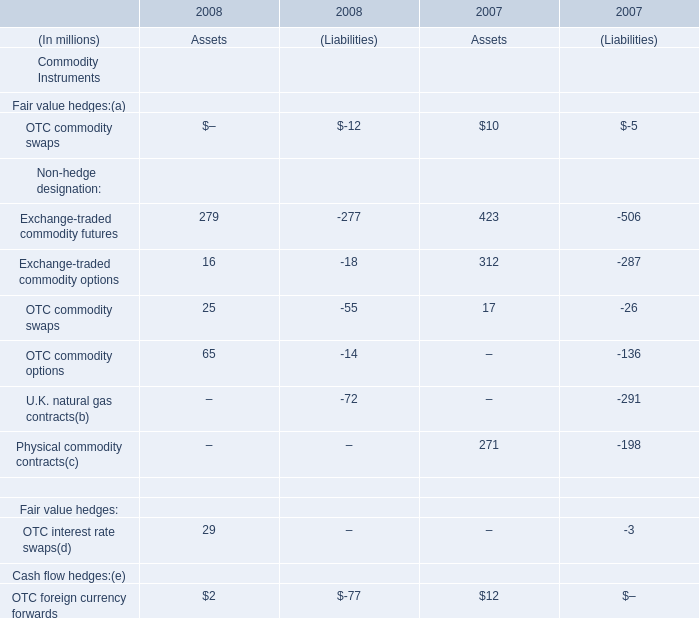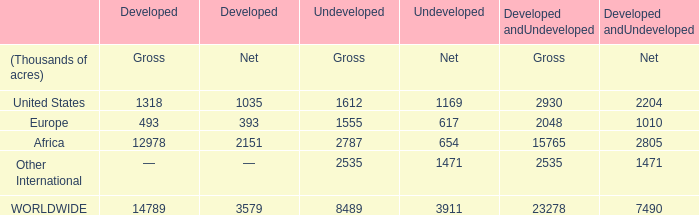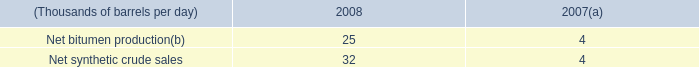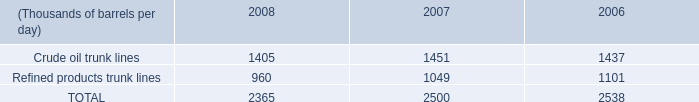what's the total amount of Europe of Developed andUndeveloped Gross, Crude oil trunk lines of 2006, and Africa of Developed andUndeveloped Gross ? 
Computations: ((2048.0 + 1437.0) + 15765.0)
Answer: 19250.0. 